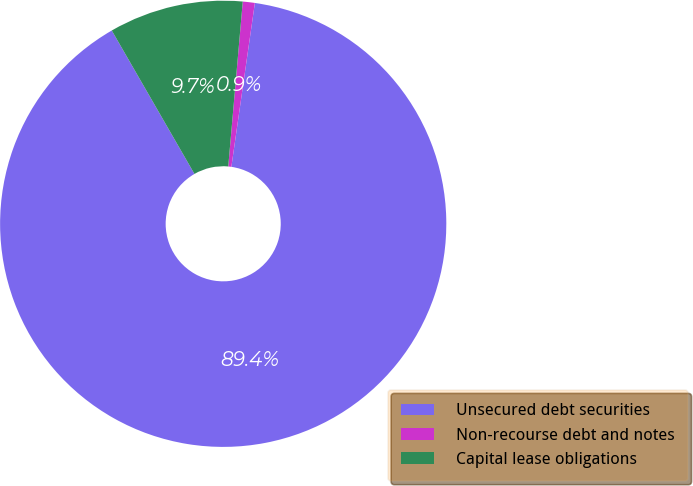Convert chart. <chart><loc_0><loc_0><loc_500><loc_500><pie_chart><fcel>Unsecured debt securities<fcel>Non-recourse debt and notes<fcel>Capital lease obligations<nl><fcel>89.41%<fcel>0.87%<fcel>9.72%<nl></chart> 